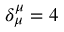<formula> <loc_0><loc_0><loc_500><loc_500>\delta _ { \mu } ^ { \mu } = 4</formula> 